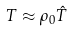Convert formula to latex. <formula><loc_0><loc_0><loc_500><loc_500>T \approx \rho _ { 0 } { \hat { T } }</formula> 